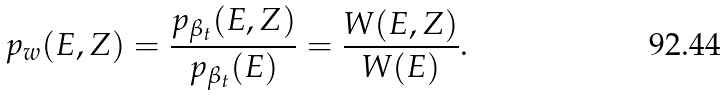Convert formula to latex. <formula><loc_0><loc_0><loc_500><loc_500>p _ { w } ( E , Z ) = \frac { p _ { \beta _ { t } } ( E , Z ) } { p _ { \beta _ { t } } ( E ) } = \frac { W ( E , Z ) } { W ( E ) } .</formula> 